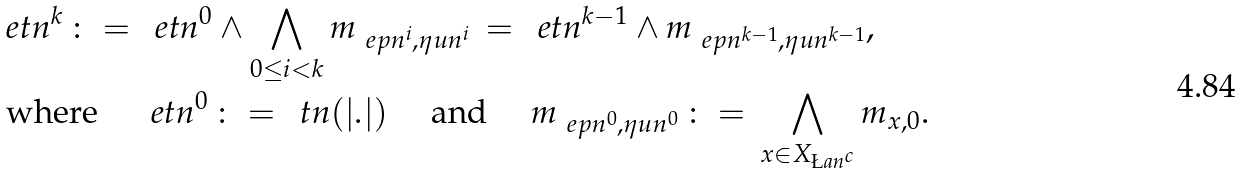<formula> <loc_0><loc_0><loc_500><loc_500>& \ e t n ^ { k } \, \colon = \, \ e t n ^ { 0 } \wedge \bigwedge _ { 0 \leq i < k } m _ { \ e p n ^ { i } , \eta u n ^ { i } } \, = \, \ e t n ^ { k - 1 } \wedge m _ { \ e p n ^ { k - 1 } , \eta u n ^ { k - 1 } } , \\ & \text { where } \quad \ e t n ^ { 0 } \, \colon = \, \ t n ( | . | ) \quad \text { and } \quad m _ { \ e p n ^ { 0 } , \eta u n ^ { 0 } } \, \colon = \, \bigwedge _ { x \in X _ { \L a n ^ { c } } } m _ { x , 0 } .</formula> 